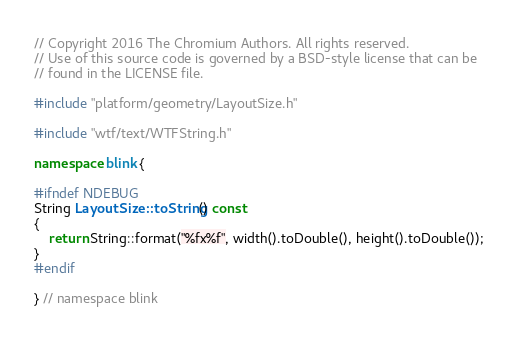Convert code to text. <code><loc_0><loc_0><loc_500><loc_500><_C++_>// Copyright 2016 The Chromium Authors. All rights reserved.
// Use of this source code is governed by a BSD-style license that can be
// found in the LICENSE file.

#include "platform/geometry/LayoutSize.h"

#include "wtf/text/WTFString.h"

namespace blink {

#ifndef NDEBUG
String LayoutSize::toString() const
{
    return String::format("%fx%f", width().toDouble(), height().toDouble());
}
#endif

} // namespace blink
</code> 